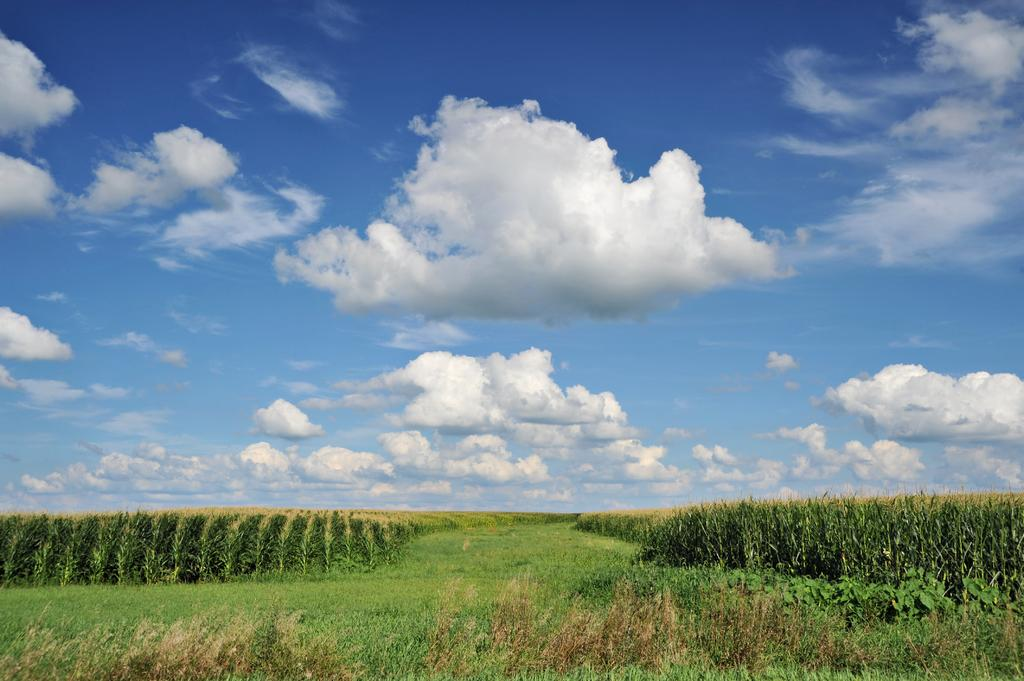What type of vegetation is present in the image? There is grass and plants on the ground in the image. What can be seen in the background of the image? There are clouds in the background of the image. What color is the sky in the image? The sky is blue in the image. What type of creature is attacking the plants in the image? There is no creature present in the image, and the plants are not being attacked. 